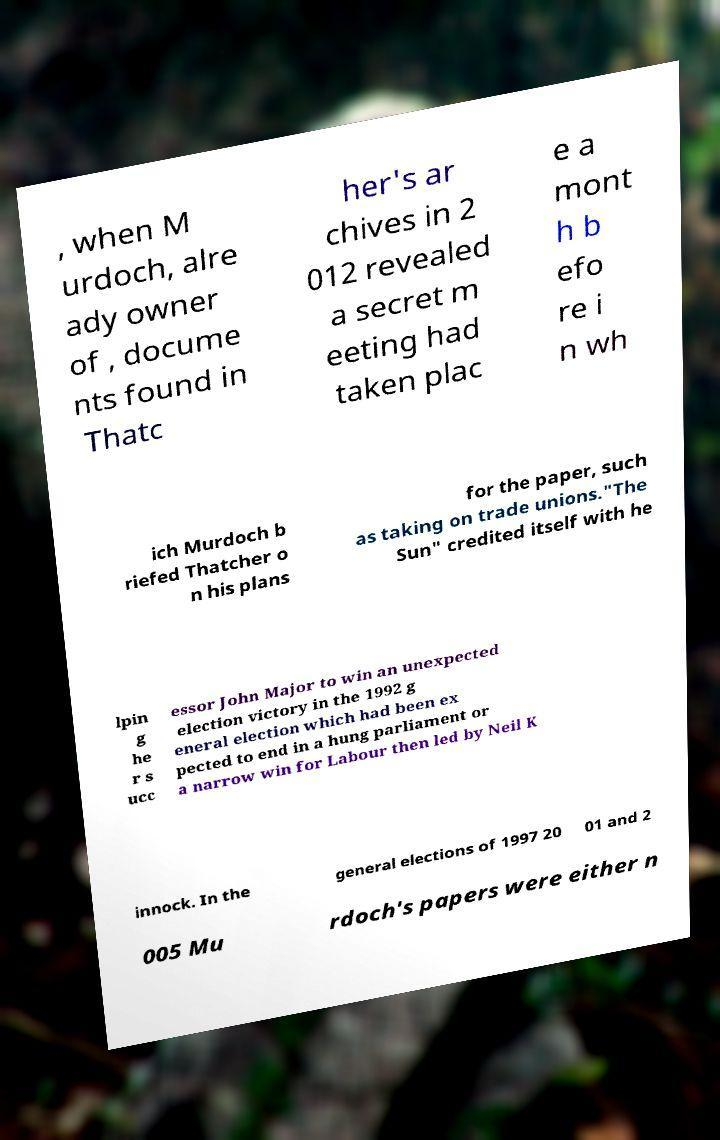What messages or text are displayed in this image? I need them in a readable, typed format. , when M urdoch, alre ady owner of , docume nts found in Thatc her's ar chives in 2 012 revealed a secret m eeting had taken plac e a mont h b efo re i n wh ich Murdoch b riefed Thatcher o n his plans for the paper, such as taking on trade unions."The Sun" credited itself with he lpin g he r s ucc essor John Major to win an unexpected election victory in the 1992 g eneral election which had been ex pected to end in a hung parliament or a narrow win for Labour then led by Neil K innock. In the general elections of 1997 20 01 and 2 005 Mu rdoch's papers were either n 